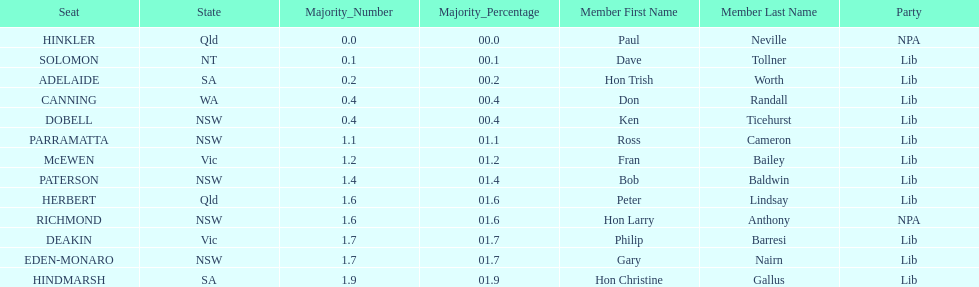What party had the most seats? Lib. 